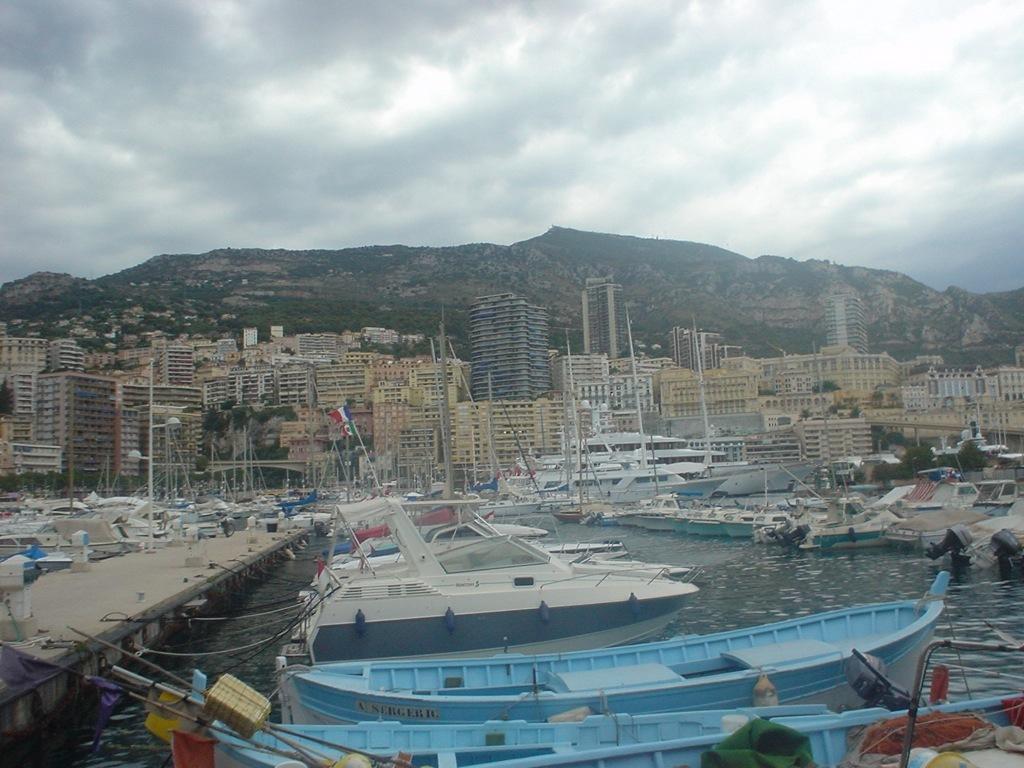Describe this image in one or two sentences. In this image at the bottom, there are boats, water, bridge. In the middle there are buildings, boats, flags, hills, trees, sky and clouds. 